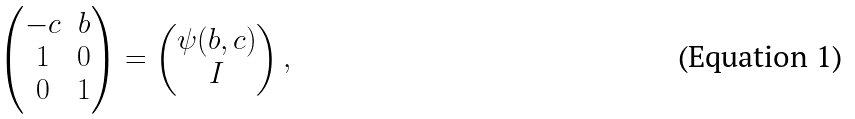Convert formula to latex. <formula><loc_0><loc_0><loc_500><loc_500>\begin{pmatrix} - c & b \\ 1 & 0 \\ 0 & 1 \end{pmatrix} = \begin{pmatrix} \psi ( b , c ) \\ I \end{pmatrix} ,</formula> 